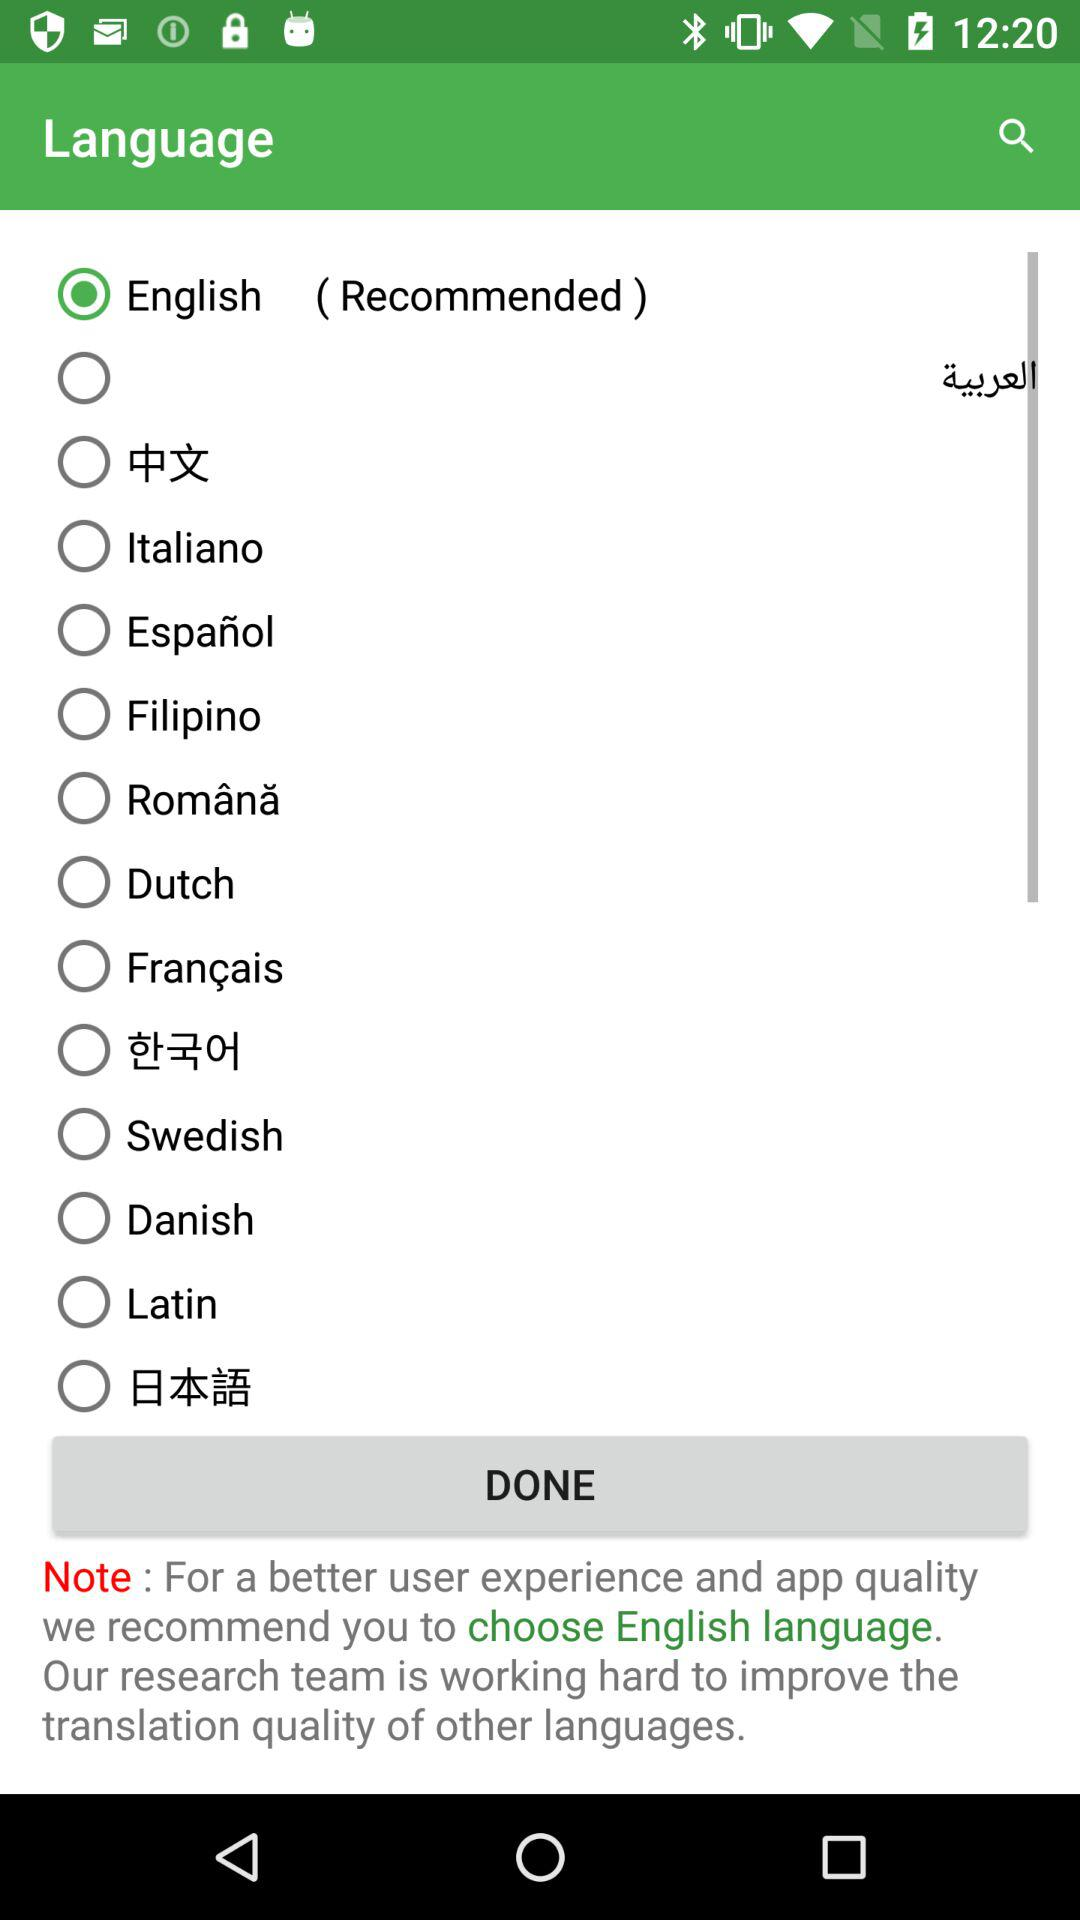What's the recommended language? The recommended language is English. 